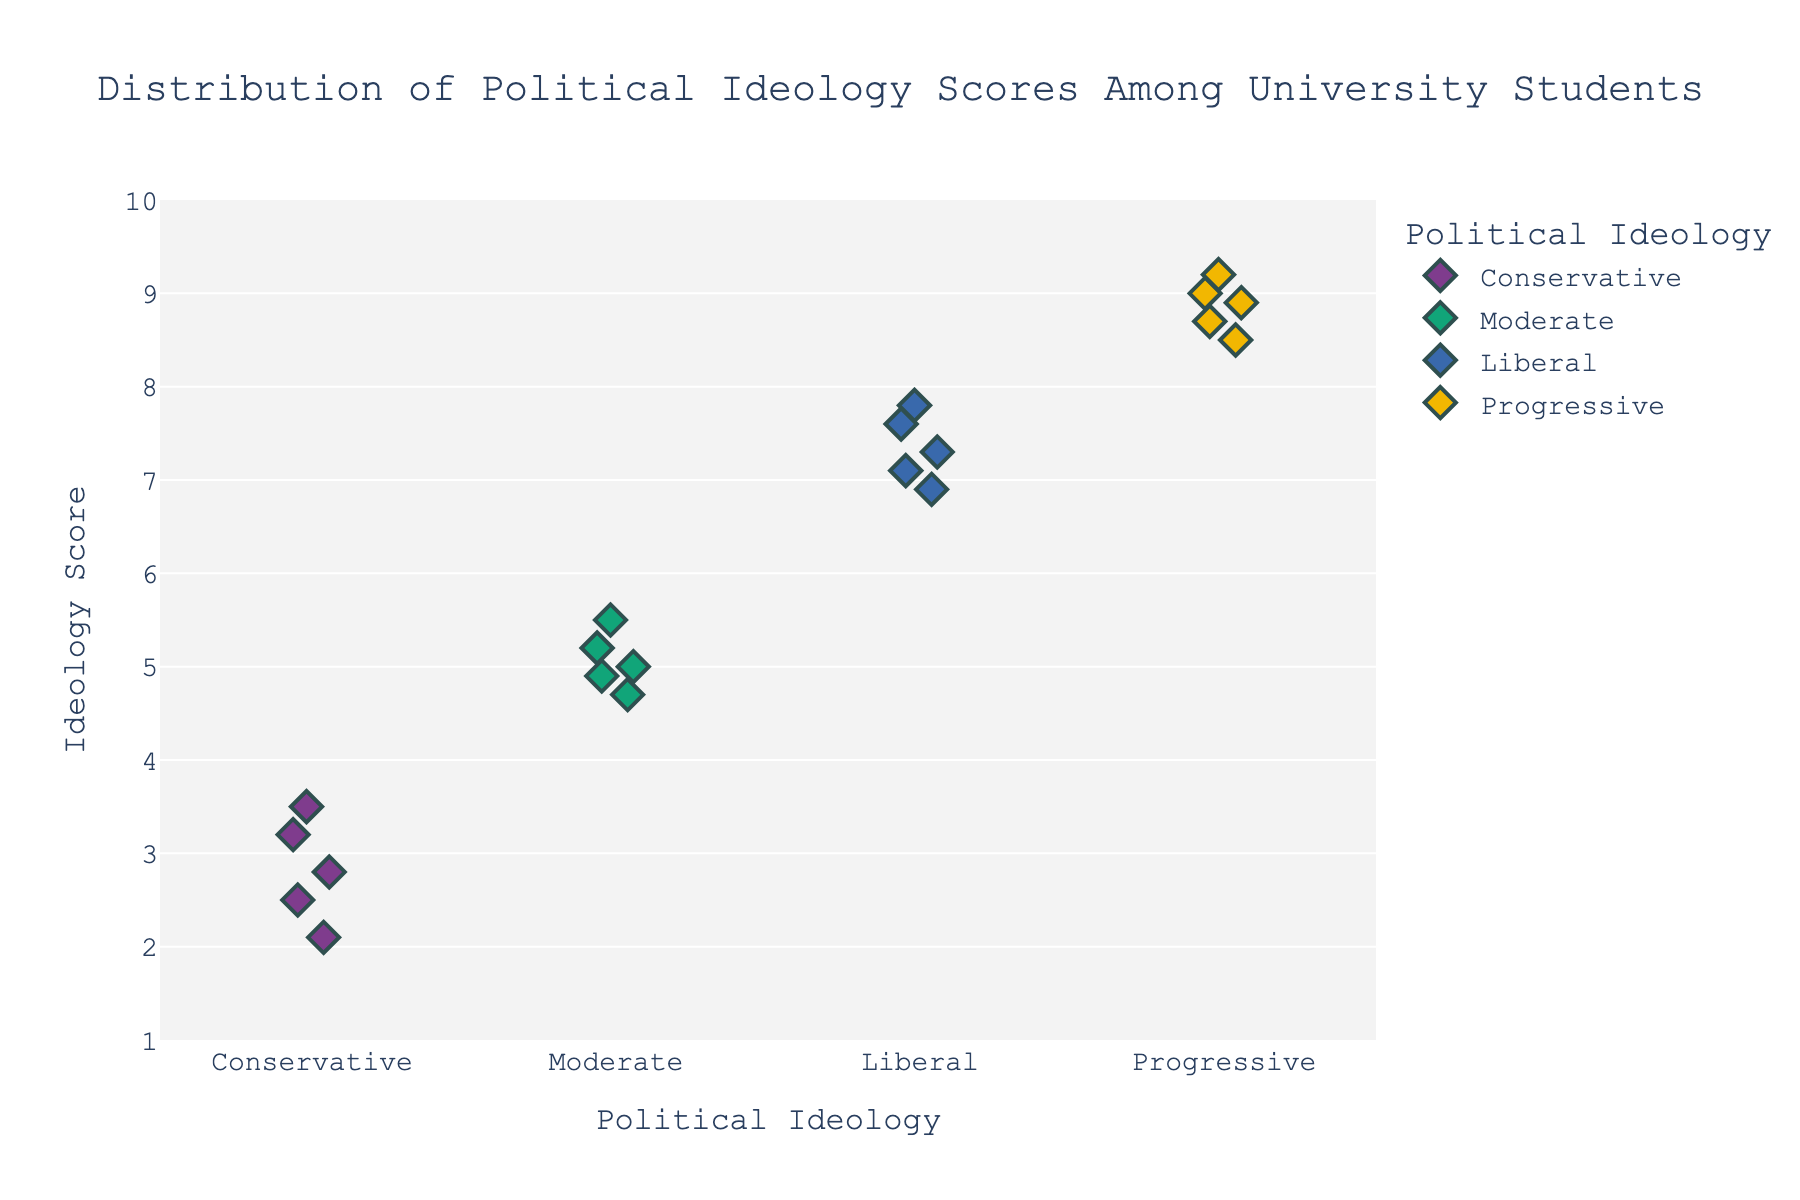How many data points are there for each political ideology? By counting the dots for each category on the strip plot, we see 5 points for "Conservative," 5 for "Moderate," 5 for "Liberal," and 5 for "Progressive."
Answer: 5 for each What is the range of ideology scores for the "Liberal" group? The lowest score is 6.9 and the highest score is 7.8 for the "Liberal" group.
Answer: 6.9 to 7.8 Which political ideology group has the highest score? Observing the y-axis and the dots, the highest score, 9.2, belongs to the "Progressive" group.
Answer: Progressive How does the spread of scores for the "Conservative" group compare to the "Moderate" group? The scores for "Conservative" range from 2.1 to 3.5, while the "Moderate" scores range from 4.7 to 5.5. The spread for "Conservatives" is wider (1.4) compared to "Moderates" (0.8).
Answer: Conservative has a wider spread What is the median score for the "Progressive" group? Arranging the scores (8.5, 8.7, 8.9, 9.0, 9.2) and finding the middle value, the median score for "Progressive" is 8.9.
Answer: 8.9 Which group shows the least variability in scores? By observing the compactness of the dots, the "Moderate" group has the least variability with scores ranging from 4.7 to 5.5.
Answer: Moderate What is the average score for the "Moderate" group? Adding all scores for "Moderate" (4.9 + 5.2 + 5.0 + 4.7 + 5.5) equals 25.3, then dividing by 5 gives the average score, which is 5.06.
Answer: 5.06 How do the highest scores of "Conservative" and "Liberal" groups compare? The highest score for "Conservative" is 3.5 and for "Liberal" is 7.8. Therefore, the "Liberal" group has a higher maximum score than the "Conservative" group.
Answer: Liberal has a higher maximum Describe the visual difference in the depiction of the "Moderate" vs. "Progressive" groups on the plot. The "Moderate" scores are tightly clustered together between 4.7 and 5.5, while the "Progressive" scores are more spread out between 8.5 and 9.2.
Answer: Moderate is tightly clustered; Progressive is more spread out 